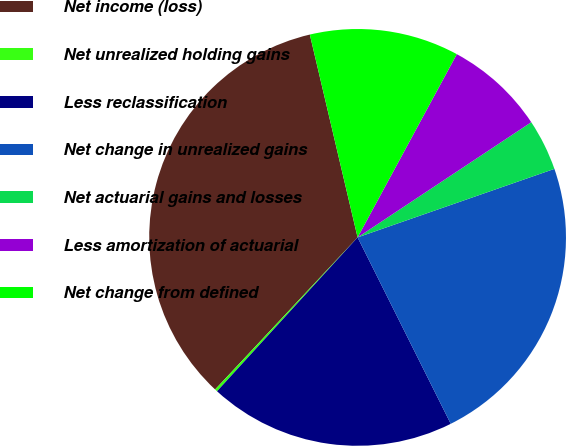Convert chart to OTSL. <chart><loc_0><loc_0><loc_500><loc_500><pie_chart><fcel>Net income (loss)<fcel>Net unrealized holding gains<fcel>Less reclassification<fcel>Net change in unrealized gains<fcel>Net actuarial gains and losses<fcel>Less amortization of actuarial<fcel>Net change from defined<nl><fcel>34.34%<fcel>0.2%<fcel>19.16%<fcel>22.96%<fcel>3.99%<fcel>7.78%<fcel>11.58%<nl></chart> 